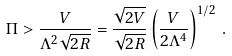Convert formula to latex. <formula><loc_0><loc_0><loc_500><loc_500>\Pi > \frac { V } { \Lambda ^ { 2 } \sqrt { 2 R } } = \frac { \sqrt { 2 V } } { \sqrt { 2 R } } \left ( \frac { V } { 2 \Lambda ^ { 4 } } \right ) ^ { 1 / 2 } \, .</formula> 